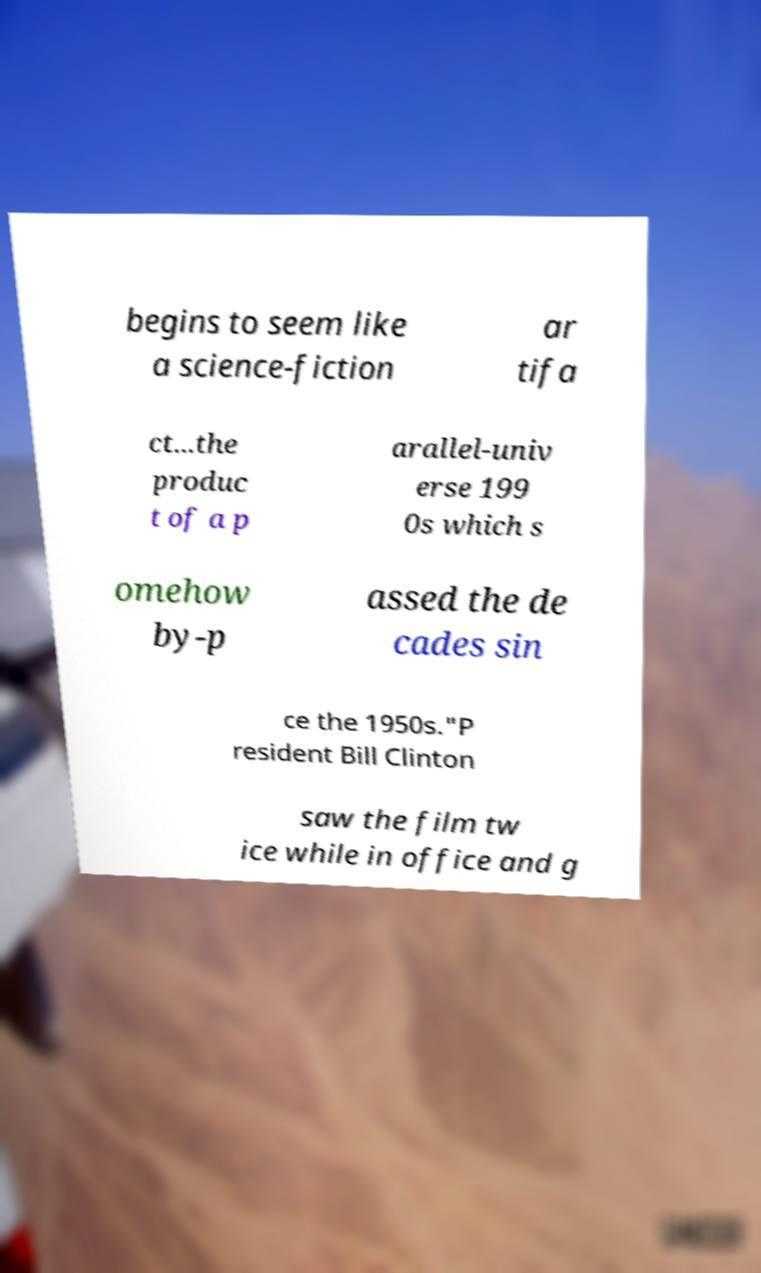Please read and relay the text visible in this image. What does it say? begins to seem like a science-fiction ar tifa ct...the produc t of a p arallel-univ erse 199 0s which s omehow by-p assed the de cades sin ce the 1950s."P resident Bill Clinton saw the film tw ice while in office and g 